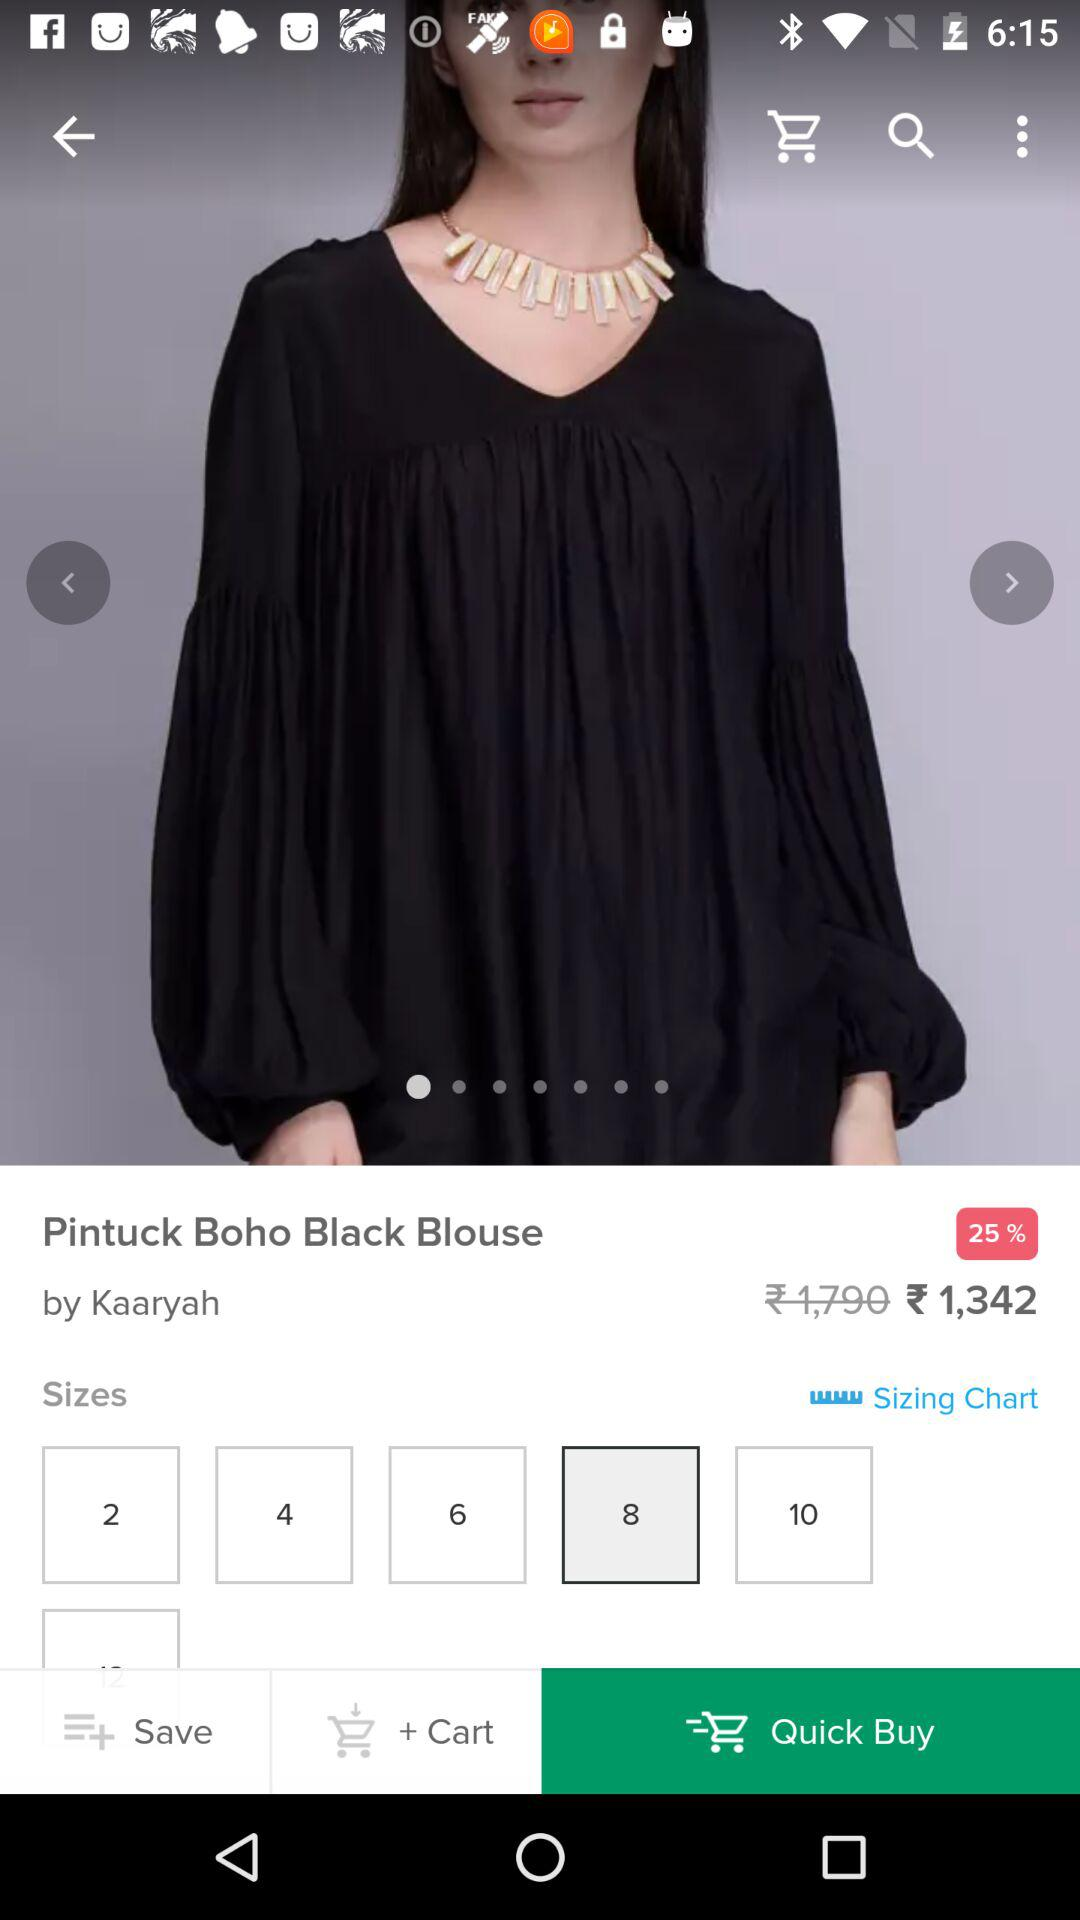What is the mentioned name? The mentioned name is Kaaryah. 